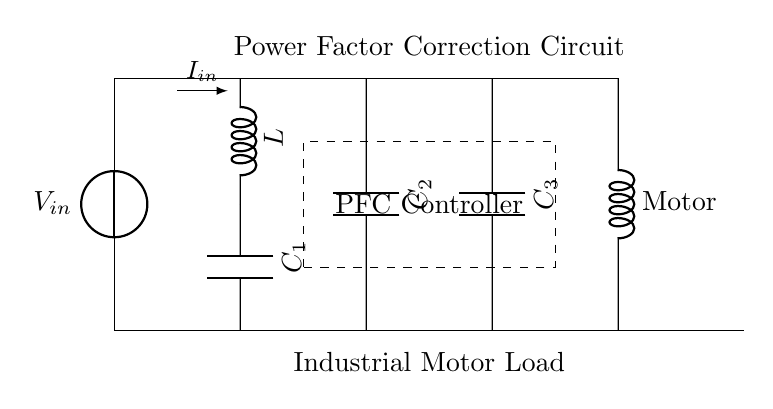What is the type of load in this circuit? The load is indicated by the symbol "Motor," which represents an industrial motor.
Answer: Motor How many capacitors are present in the circuit? There are three capacitors labeled as C1, C2, and C3 in the diagram.
Answer: Three What is the purpose of the PFC Controller? The PFC (Power Factor Correction) Controller manages the reactive power in the circuit to improve energy efficiency by adjusting the capacitance.
Answer: Improve energy efficiency What is the role of the inductor in this circuit? The inductor L stores energy in a magnetic field and helps in controlling the current flow, contributing to the power factor correction.
Answer: Control current flow How does the current flow in the circuit? The current flows from the voltage source through the inductor and capacitors before reaching the motor, as indicated by the direction of the arrows.
Answer: From source to motor Why is power factor correction critical in industrial motors? Power factor correction reduces wasted electrical power, which improves energy efficiency and reduces costs associated with poor power factors.
Answer: Reduce wasted power 